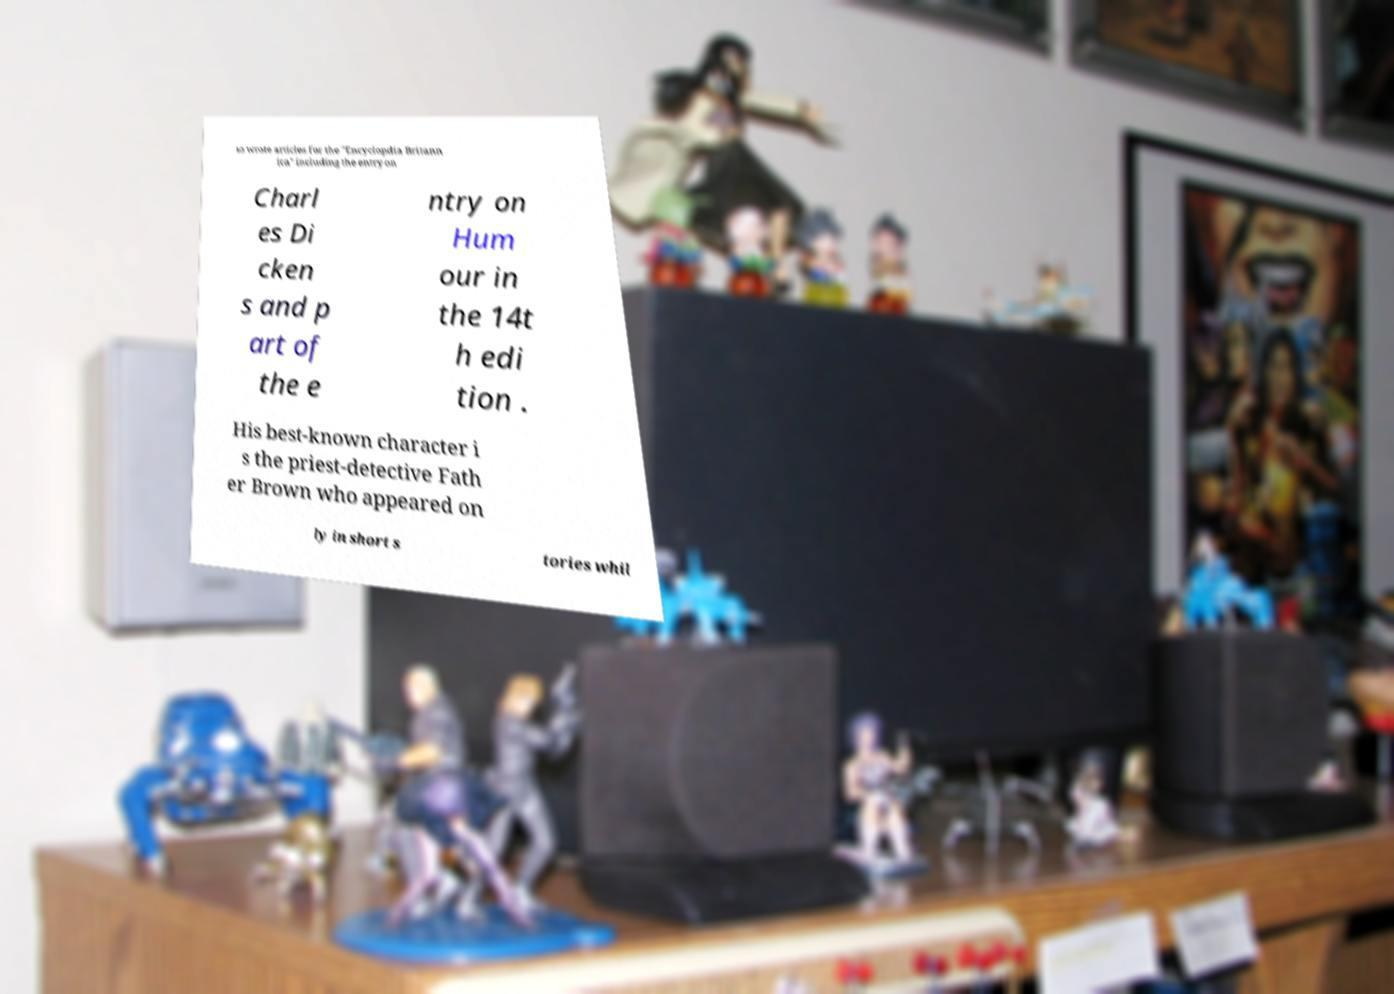What messages or text are displayed in this image? I need them in a readable, typed format. so wrote articles for the "Encyclopdia Britann ica" including the entry on Charl es Di cken s and p art of the e ntry on Hum our in the 14t h edi tion . His best-known character i s the priest-detective Fath er Brown who appeared on ly in short s tories whil 